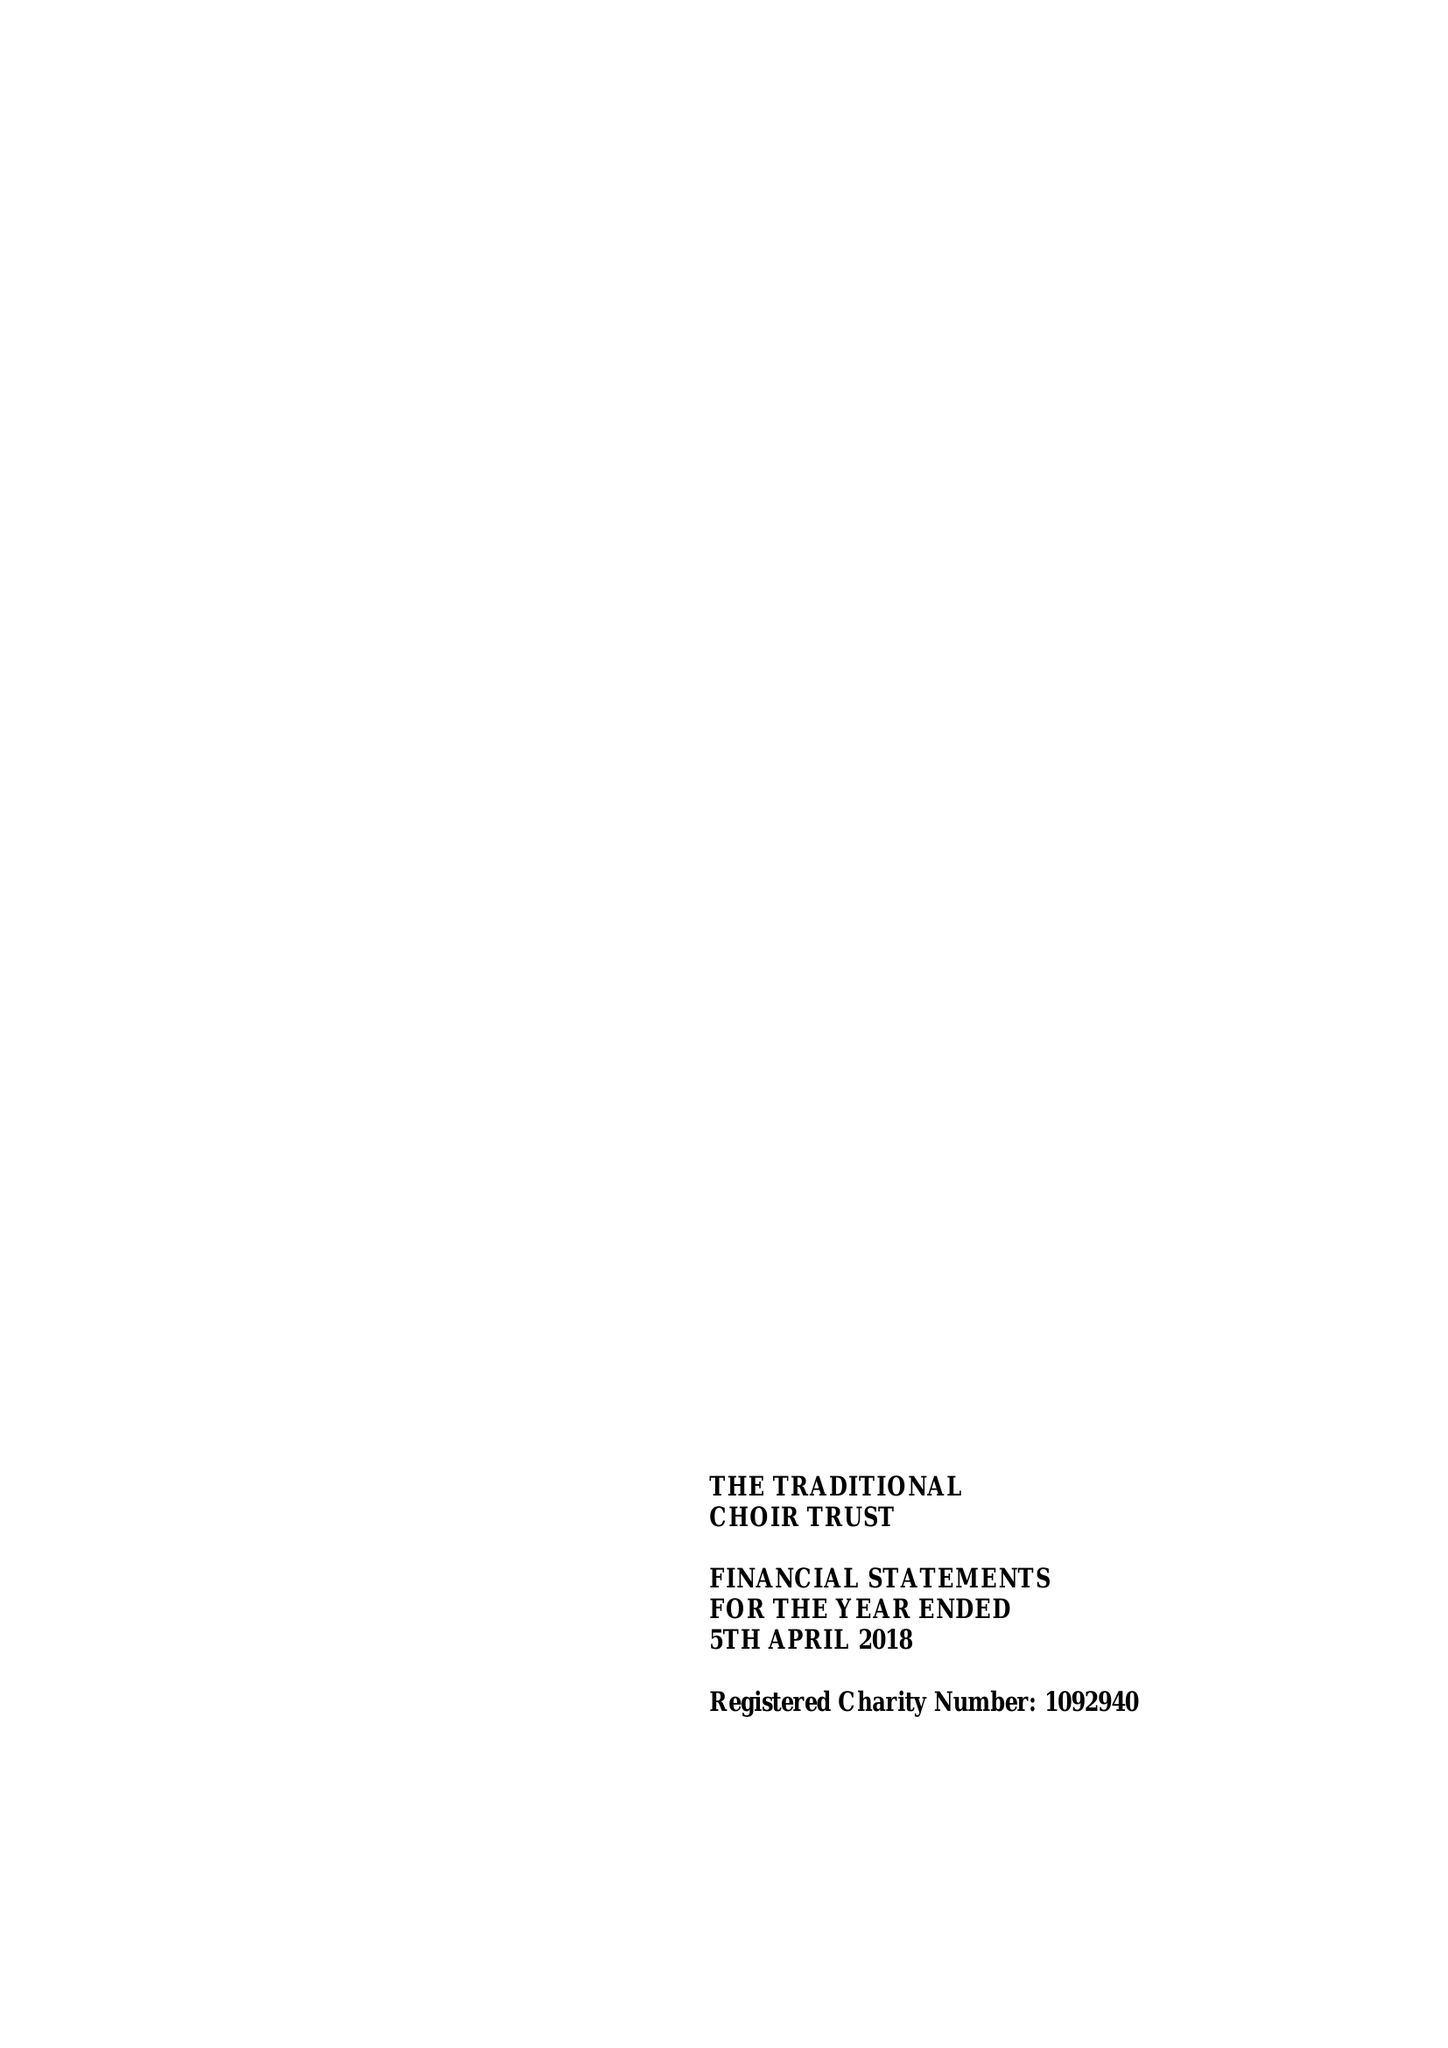What is the value for the address__postcode?
Answer the question using a single word or phrase. PO19 1PX 